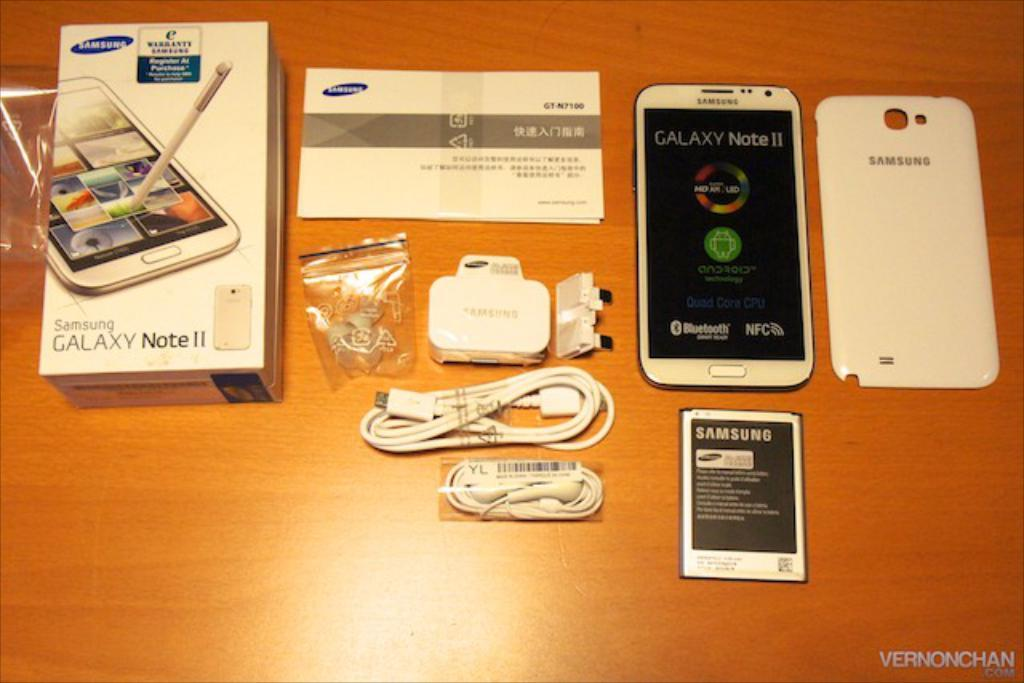<image>
Render a clear and concise summary of the photo. A box held a new samsung galaxy note II. 